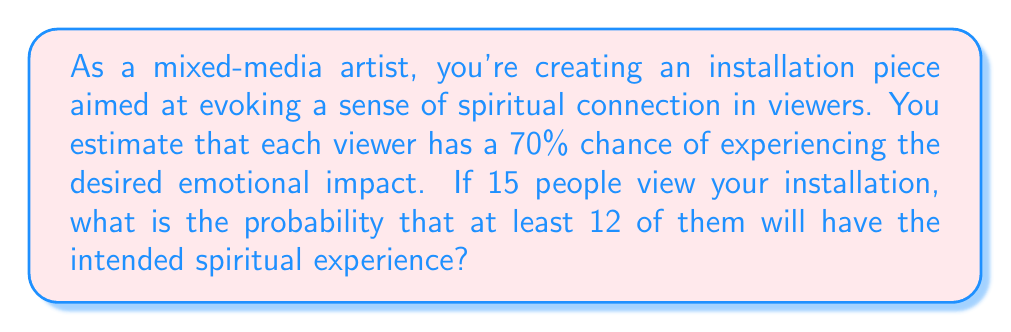What is the answer to this math problem? Let's approach this step-by-step using the binomial distribution:

1) Define the random variable:
   Let $X$ be the number of viewers who experience the desired emotional impact.

2) Identify the parameters:
   $n = 15$ (number of trials/viewers)
   $p = 0.70$ (probability of success for each viewer)
   $q = 1 - p = 0.30$ (probability of failure for each viewer)

3) We want to find $P(X \geq 12)$. This is equivalent to:
   $P(X \geq 12) = 1 - P(X \leq 11)$

4) Using the binomial distribution formula:
   $$P(X = k) = \binom{n}{k} p^k q^{n-k}$$

5) We need to calculate:
   $$1 - [P(X = 0) + P(X = 1) + ... + P(X = 11)]$$

6) Let's use the cumulative binomial probability function:
   $$P(X \geq 12) = 1 - P(X \leq 11) = 1 - \sum_{k=0}^{11} \binom{15}{k} (0.70)^k (0.30)^{15-k}$$

7) Using a calculator or computer (as this involves complex calculations):
   $$P(X \geq 12) \approx 0.1909$$

Thus, there is approximately a 19.09% chance that at least 12 out of 15 viewers will experience the desired emotional impact.
Answer: $0.1909$ or $19.09\%$ 